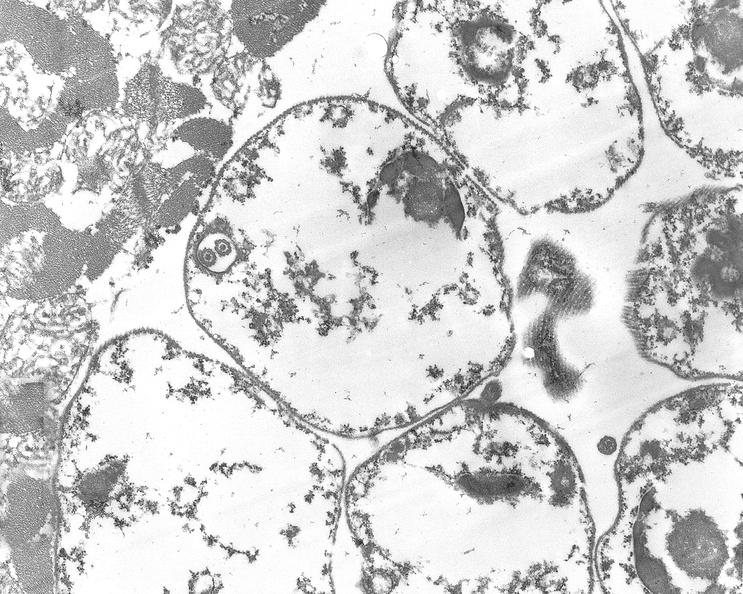does this image show chagas disease, acute, trypanasoma cruzi?
Answer the question using a single word or phrase. Yes 